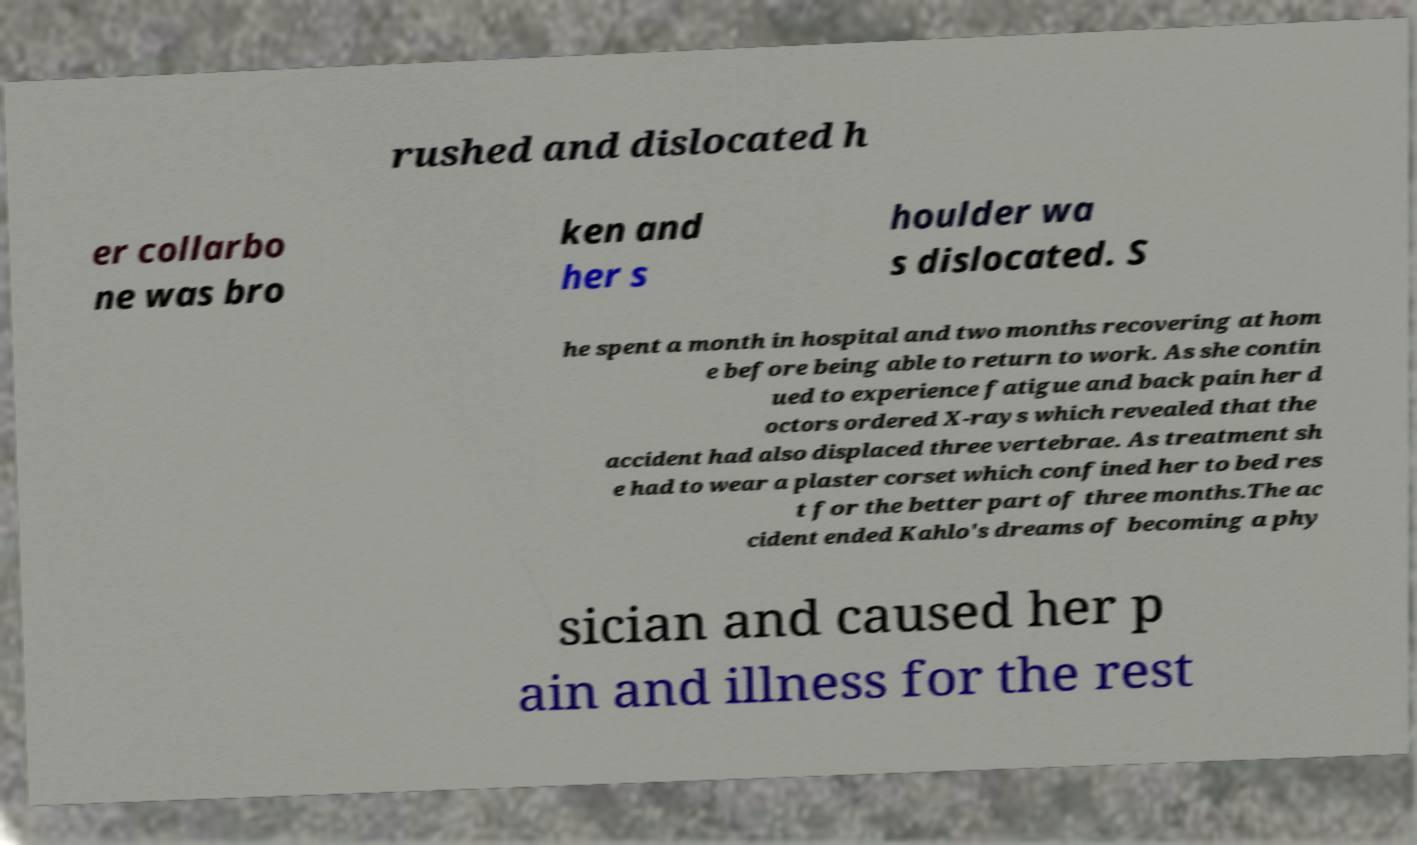For documentation purposes, I need the text within this image transcribed. Could you provide that? rushed and dislocated h er collarbo ne was bro ken and her s houlder wa s dislocated. S he spent a month in hospital and two months recovering at hom e before being able to return to work. As she contin ued to experience fatigue and back pain her d octors ordered X-rays which revealed that the accident had also displaced three vertebrae. As treatment sh e had to wear a plaster corset which confined her to bed res t for the better part of three months.The ac cident ended Kahlo's dreams of becoming a phy sician and caused her p ain and illness for the rest 